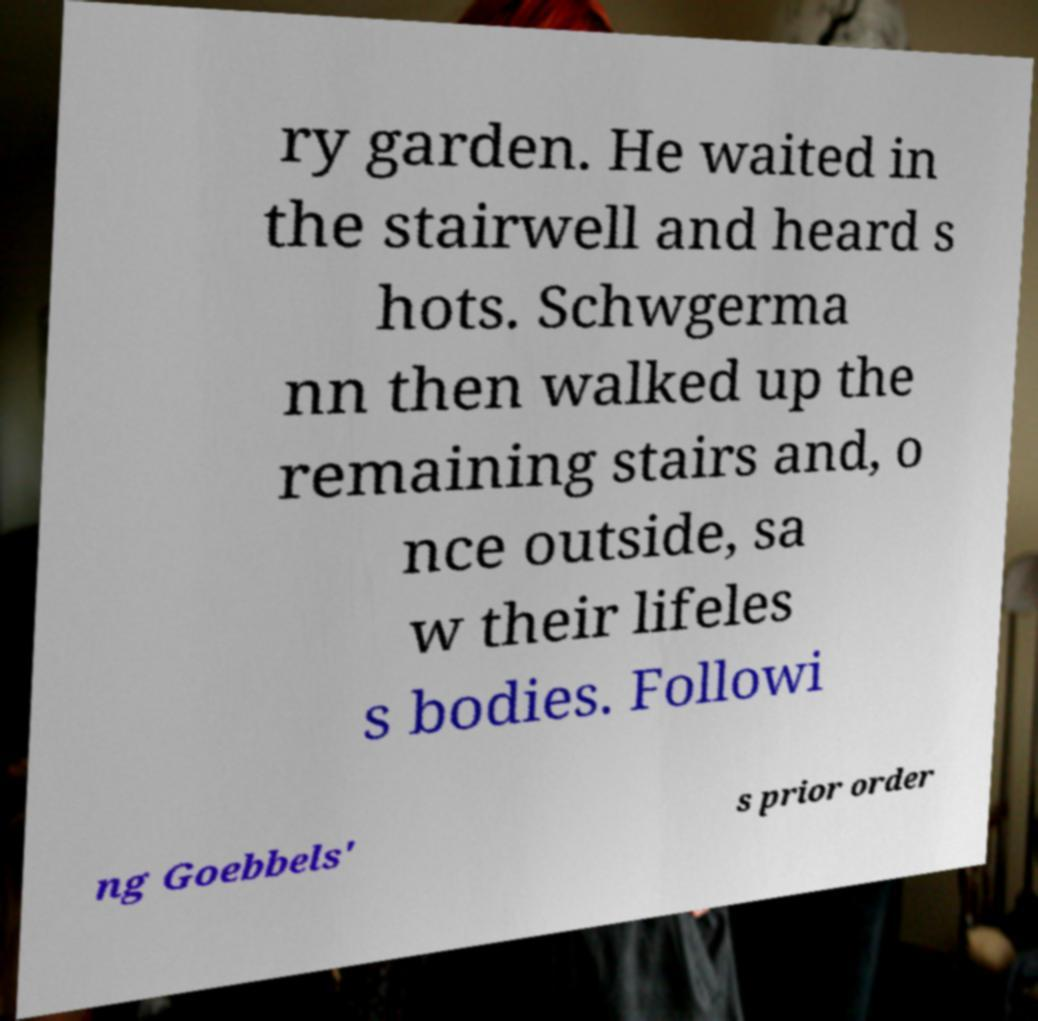There's text embedded in this image that I need extracted. Can you transcribe it verbatim? ry garden. He waited in the stairwell and heard s hots. Schwgerma nn then walked up the remaining stairs and, o nce outside, sa w their lifeles s bodies. Followi ng Goebbels' s prior order 